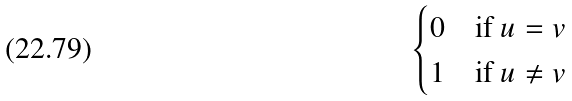Convert formula to latex. <formula><loc_0><loc_0><loc_500><loc_500>\begin{cases} 0 \quad \text {if } u = v \\ 1 \quad \text {if } u \neq v \end{cases}</formula> 